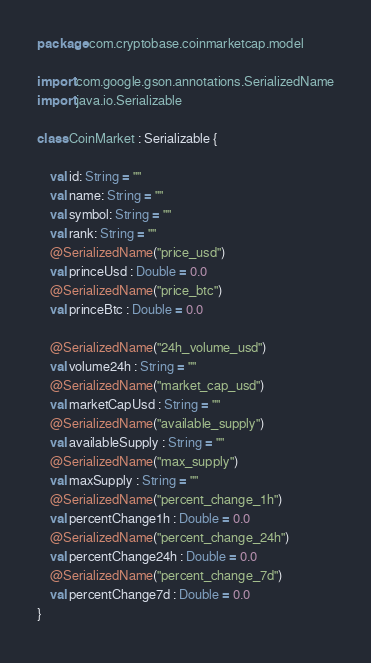<code> <loc_0><loc_0><loc_500><loc_500><_Kotlin_>package com.cryptobase.coinmarketcap.model

import com.google.gson.annotations.SerializedName
import java.io.Serializable

class CoinMarket : Serializable {

    val id: String = ""
    val name: String = ""
    val symbol: String = ""
    val rank: String = ""
    @SerializedName("price_usd")
    val princeUsd : Double = 0.0
    @SerializedName("price_btc")
    val princeBtc : Double = 0.0

    @SerializedName("24h_volume_usd")
    val volume24h : String = ""
    @SerializedName("market_cap_usd")
    val marketCapUsd : String = ""
    @SerializedName("available_supply")
    val availableSupply : String = ""
    @SerializedName("max_supply")
    val maxSupply : String = ""
    @SerializedName("percent_change_1h")
    val percentChange1h : Double = 0.0
    @SerializedName("percent_change_24h")
    val percentChange24h : Double = 0.0
    @SerializedName("percent_change_7d")
    val percentChange7d : Double = 0.0
}
</code> 